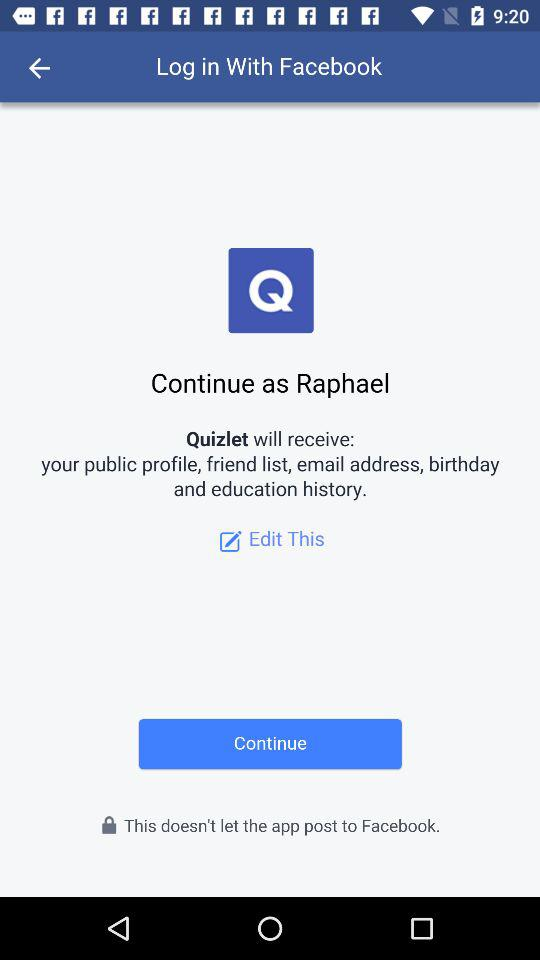What application is asking for permission? The application asking for permission is "Quizlet". 